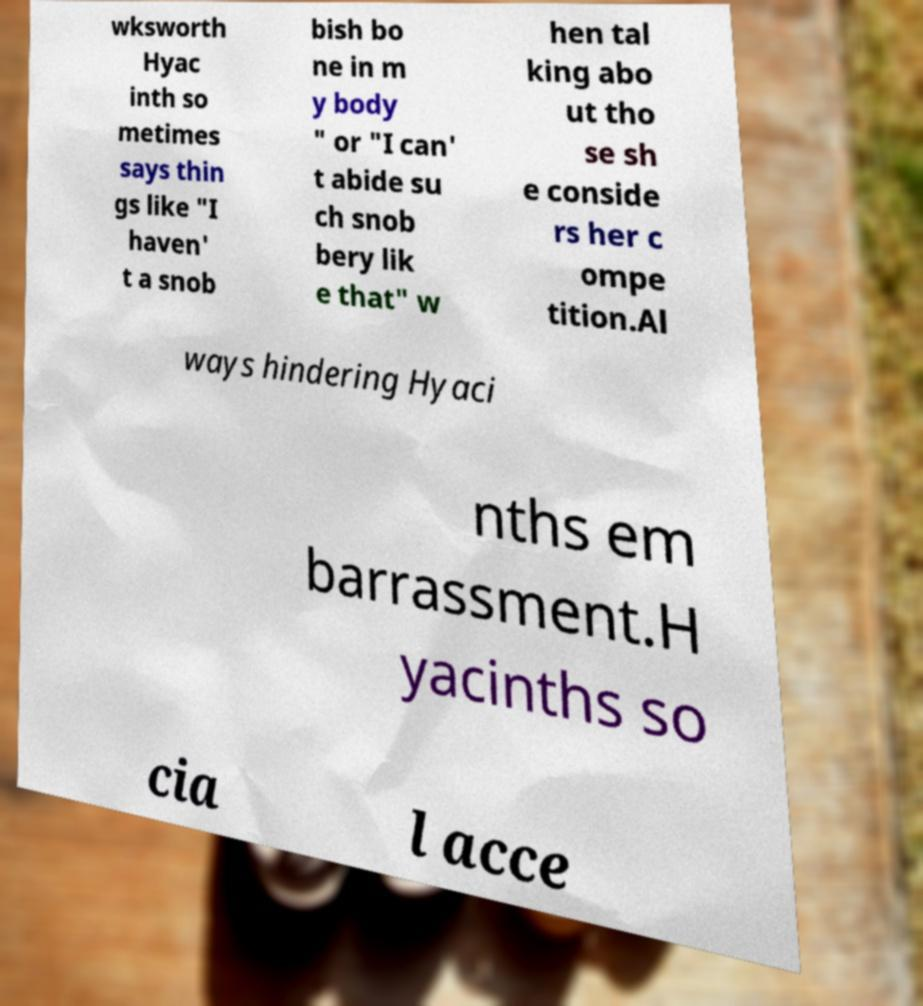Can you accurately transcribe the text from the provided image for me? wksworth Hyac inth so metimes says thin gs like "I haven' t a snob bish bo ne in m y body " or "I can' t abide su ch snob bery lik e that" w hen tal king abo ut tho se sh e conside rs her c ompe tition.Al ways hindering Hyaci nths em barrassment.H yacinths so cia l acce 